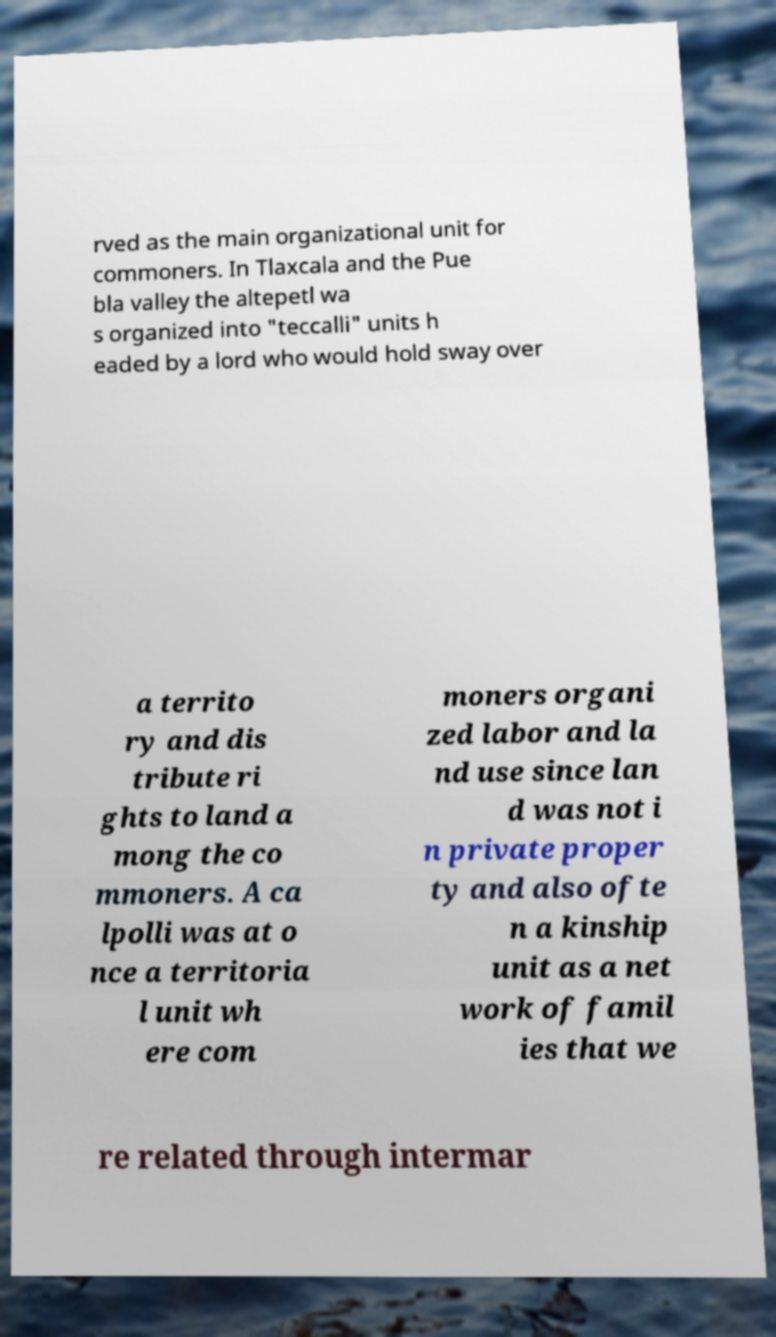For documentation purposes, I need the text within this image transcribed. Could you provide that? rved as the main organizational unit for commoners. In Tlaxcala and the Pue bla valley the altepetl wa s organized into "teccalli" units h eaded by a lord who would hold sway over a territo ry and dis tribute ri ghts to land a mong the co mmoners. A ca lpolli was at o nce a territoria l unit wh ere com moners organi zed labor and la nd use since lan d was not i n private proper ty and also ofte n a kinship unit as a net work of famil ies that we re related through intermar 